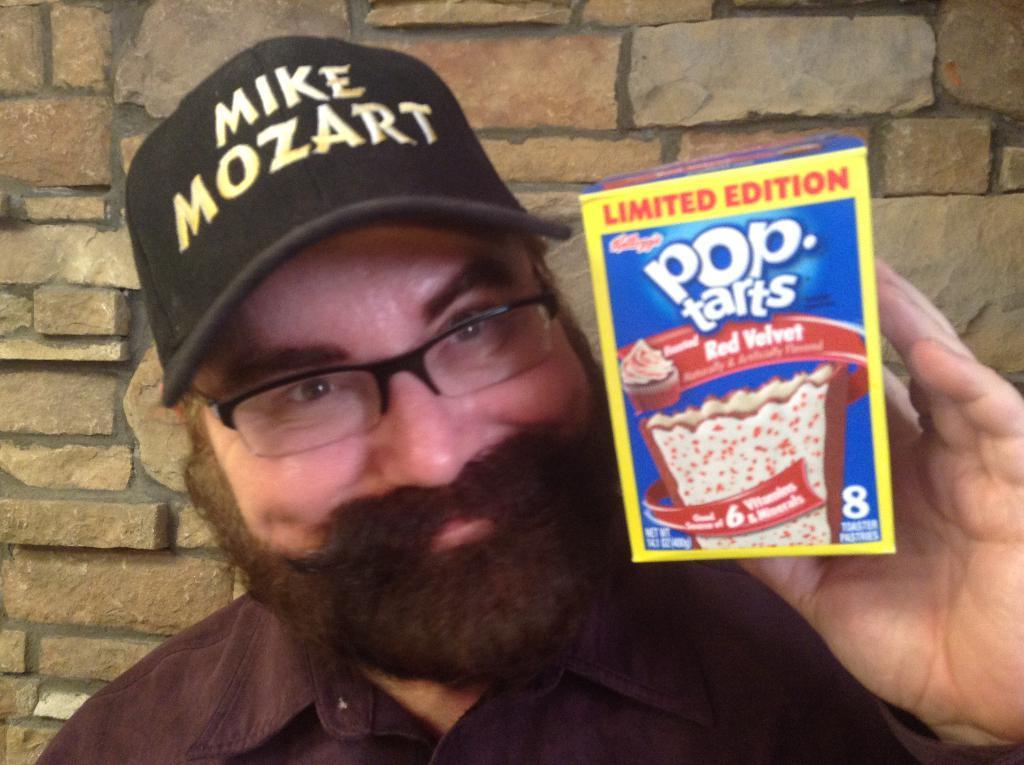In one or two sentences, can you explain what this image depicts? In this picture we can see a man wore a spectacle, cap and holding a box with his hand and smiling and in the background we can see wall. 